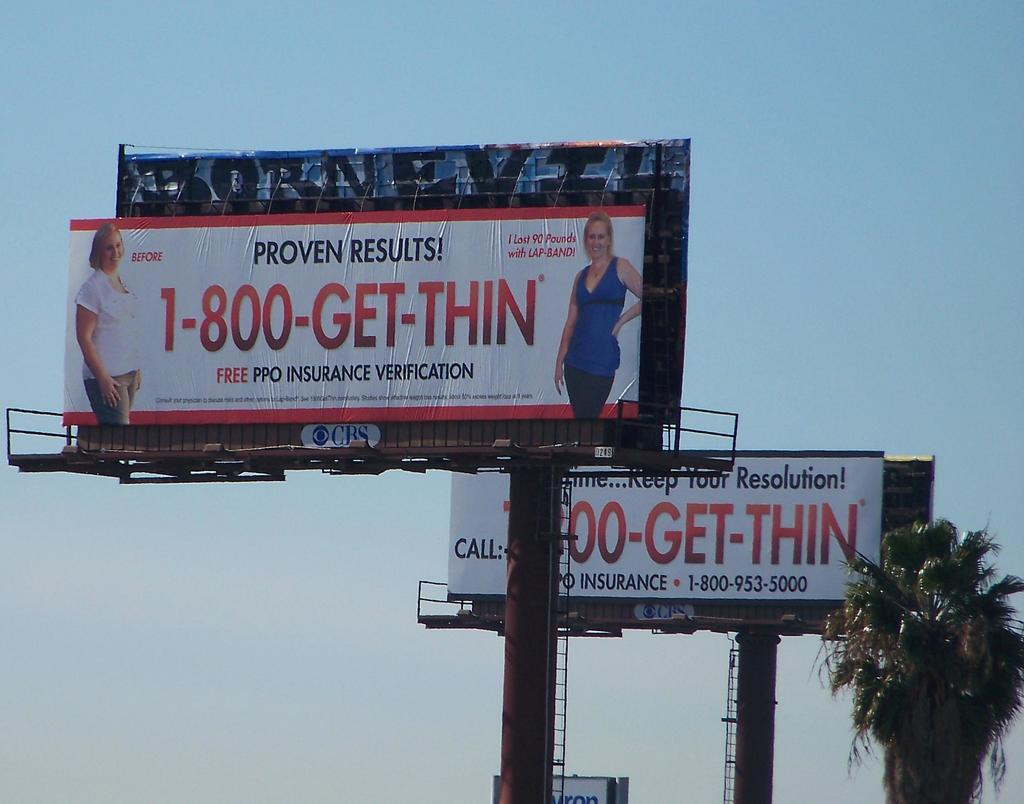<image>
Write a terse but informative summary of the picture. The image shows two billboards offering lap band surgery along with a phone number for information 